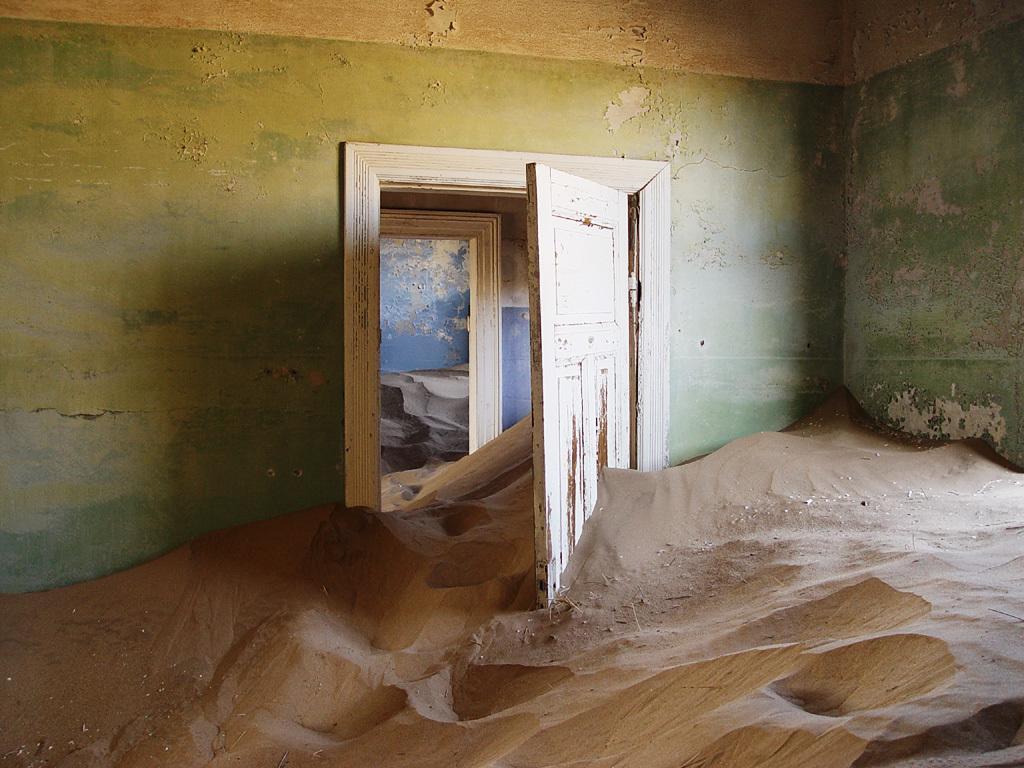Could you give a brief overview of what you see in this image? There is sand in a room which is having green color wall and white color door. In the background, there is sand in other two rooms. 